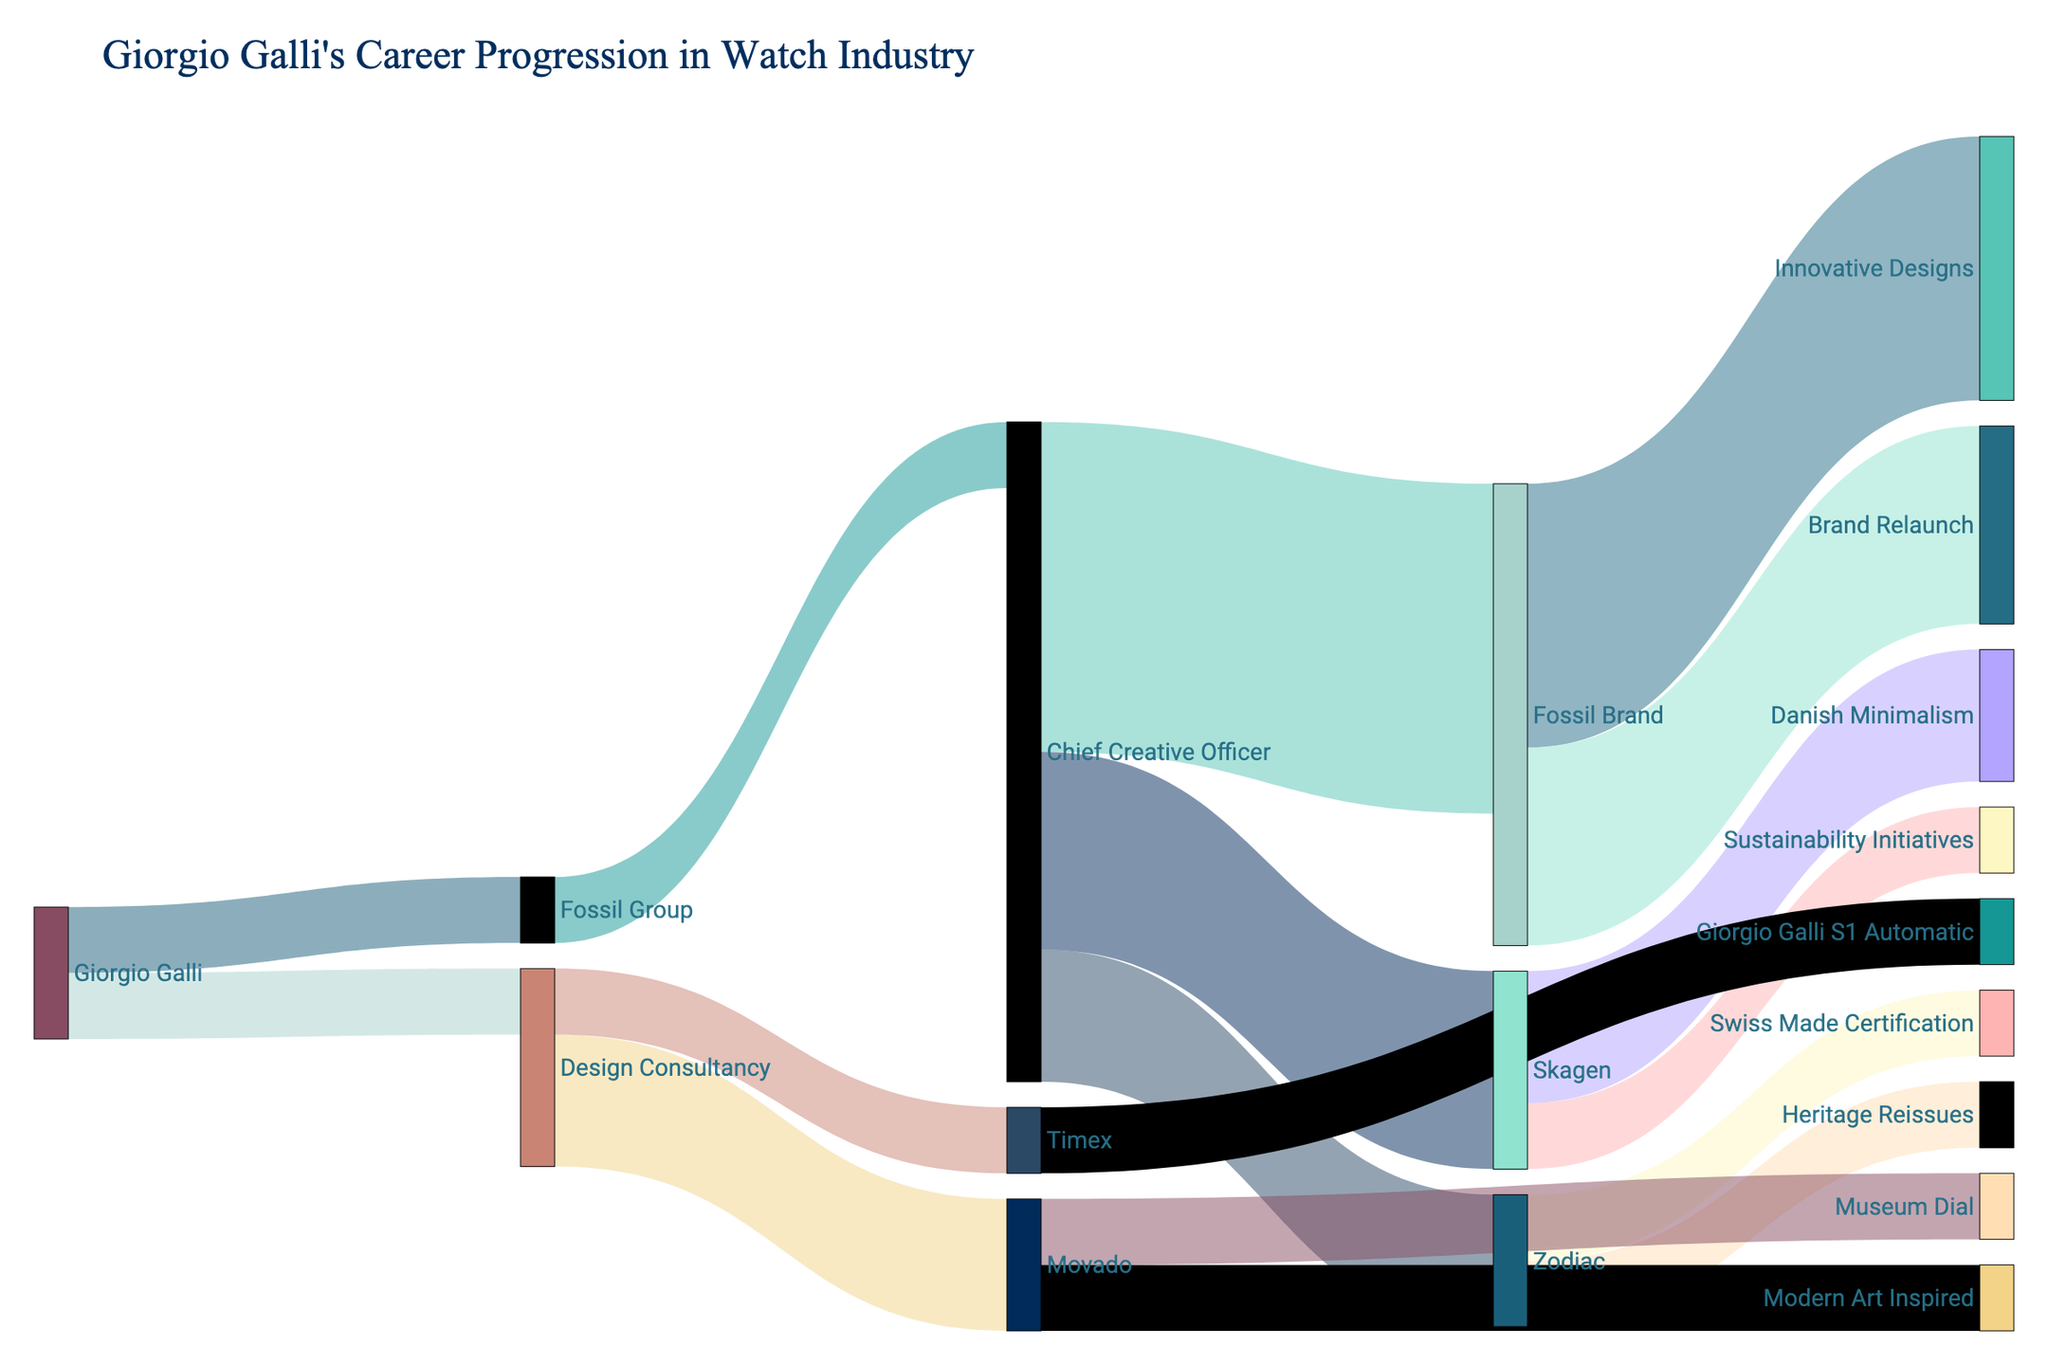Who is the Chief Creative Officer for the Fossil Group within the diagram? The Sankey diagram shows Giorgio Galli is associated with the Fossil Group. From the Fossil Group, there is a link directing to the Chief Creative Officer role. Thus, Giorgio Galli holds the title of Chief Creative Officer for the Fossil Group.
Answer: Giorgio Galli How many contributions are shown as Giorgio Galli's outputs for the Fossil Brand? The diagram indicates two contributing roles under the Fossil Brand: Innovative Designs with 4 contributions and Brand Relaunch with 3 contributions. Adding these together gives a total of 7 contributions to the Fossil Brand by Giorgio Galli.
Answer: 7 Which company did Giorgio Galli work with that is associated with Danish Minimalism? Referring to the Sankey diagram, Danish Minimalism is a contribution linked under Skagen. Since Giorgio Galli's flow includes Skagen through his role as Chief Creative Officer with the Fossil Group, it is clear that Skagen is the firm harboring Danish Minimalism in the context of his work.
Answer: Skagen What kind of design was introduced by Giorgio Galli for the Timex brand? Upon examining the flow of contributions associated with Timex within the diagram, it is evident that Giorgio Galli introduced the Giorgio Galli S1 Automatic design for this brand.
Answer: Giorgio Galli S1 Automatic Which of Giorgio Galli's roles has more associated contributions, Chief Creative Officer or Design Consultant? The Sankey diagram demonstrates that as Chief Creative Officer, Giorgio Galli is linked with Fossil Brand (5 contributions), Skagen (3 contributions), and Zodiac (2 contributions), summing up to 10 contributions. In comparison, as a Design Consultant, he is connected to Movado (2) and Timex (1), totaling 3 contributions. Therefore, the Chief Creative Officer role has more contributions.
Answer: Chief Creative Officer What are the specific features linked to Giorgio Galli’s work with the Zodiac brand? The diagram illustrates that Giorgio Galli has engaged in Heritage Reissues and achieved Swiss Made Certification at Zodiac based on the links flowing from Zodiac in the Sankey diagram.
Answer: Heritage Reissues and Swiss Made Certification Which design style is specific to Giorgio Galli's work with Movado? Reviewing the connections from Movado in the diagram shows that Giorgio Galli contributed to Modern Art Inspired and Museum Dial designs, with Museum Dial being one of the highlighted styles.
Answer: Museum Dial How many total companies did Giorgio Galli work with according to the diagram? The Source column in the Sankey diagram indicates direct associations with Fossil Group and Design Consultancy. Under these, his engagements span Fossil Brand, Skagen, Zodiac, Movado, and Timex, summing up to interactions with 5 different companies.
Answer: 5 What is the title of the Sankey diagram, and what does it signify? The title at the top of the diagram reads "Giorgio Galli's Career Progression in Watch Industry". This signifies an overview of Giorgio Galli's professional journey and contributions to different companies in the watch industry tracked through his various roles.
Answer: Giorgio Galli's Career Progression in Watch Industry 